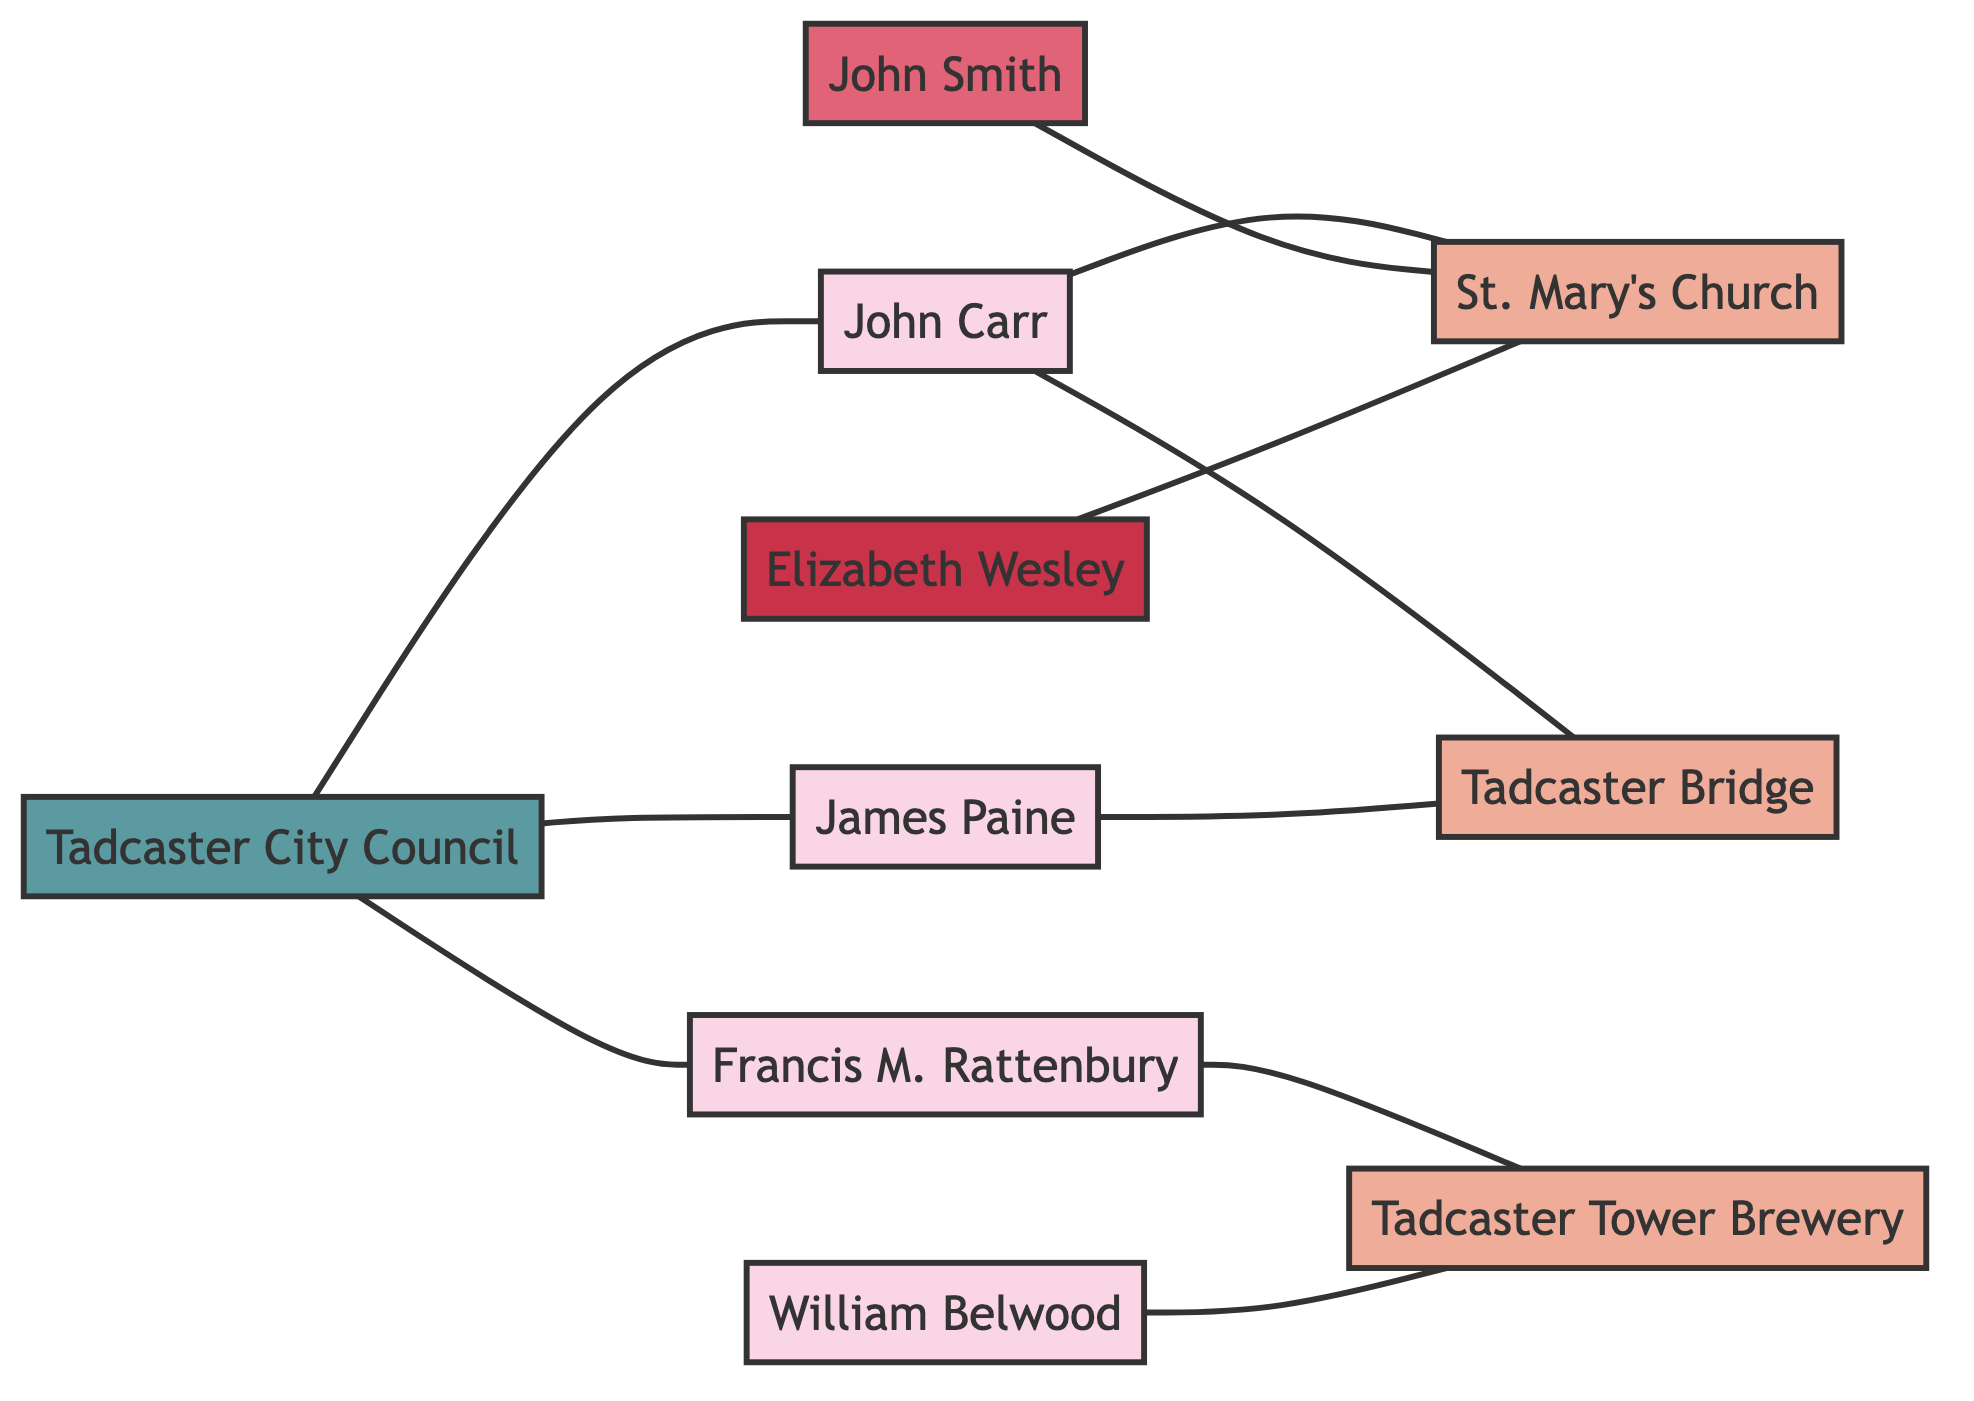What is the total number of nodes in the graph? There are 10 nodes listed in the data: 4 architects, 3 buildings, 1 builder, 1 patron, and 1 organization.
Answer: 10 Who is directly connected to Tadcaster Bridge? The Tadcaster Bridge is directly connected to John Carr and James Paine, as evidenced by the edges linking these architects to the bridge.
Answer: John Carr, James Paine Which building has the highest number of connections? St. Mary's Church is connected to three nodes: John Carr, John Smith, and Elizabeth Wesley, while other buildings have fewer connections.
Answer: St. Mary's Church How many architects are connected to Tadcaster City Council? The Tadcaster City Council has edges leading to John Carr, James Paine, and Francis Mawson Rattenbury, indicating that there are 3 architects connected to it.
Answer: 3 What type of node is Elizabeth Wesley? Elizabeth Wesley is categorized as a Patron within the node types defined in the data.
Answer: Patron How many buildings are associated with William Belwood? William Belwood is connected to only Tadcaster Tower Brewery, as shown by the edge connecting them.
Answer: 1 Which architect is associated with both St. Mary's Church and Tadcaster Bridge? The architect John Carr is associated with both St. Mary's Church and Tadcaster Bridge, as seen from the two edges connecting him.
Answer: John Carr Are there more buildings or architects in the graph? There are 4 architects and 3 buildings, making the number of architects higher than the number of buildings.
Answer: Architects What type of graph is this and why? The graph is an undirected graph because the connections (edges) between nodes do not have a designated direction, indicating mutual relationships.
Answer: Undirected Graph 